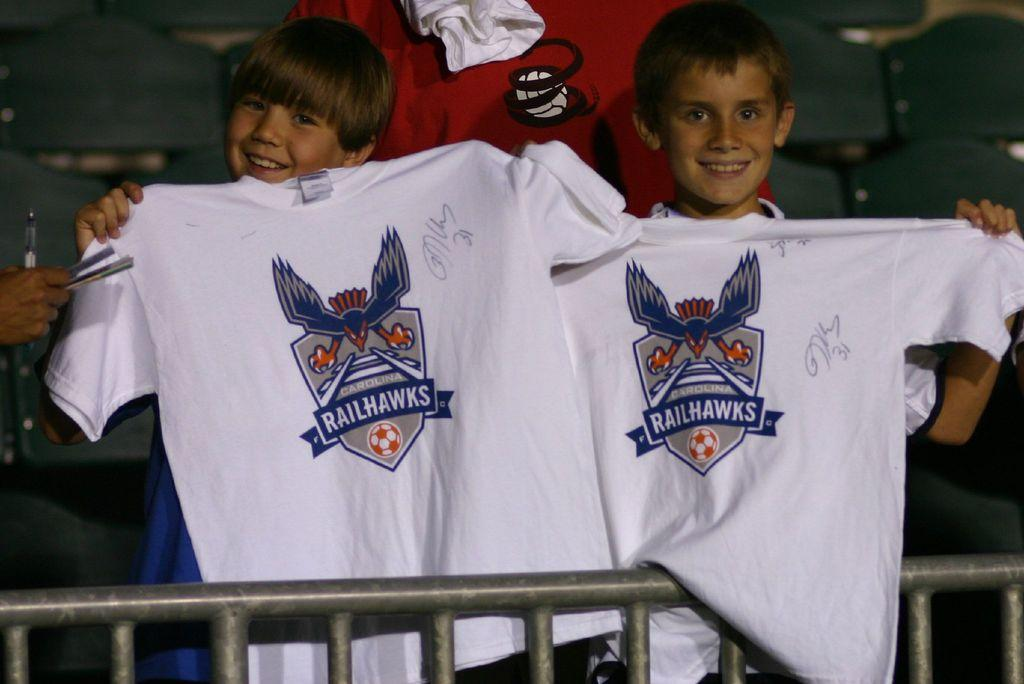<image>
Share a concise interpretation of the image provided. The kids are big fans of the Railhawks soccer team. 